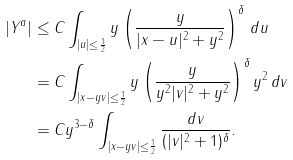Convert formula to latex. <formula><loc_0><loc_0><loc_500><loc_500>| Y ^ { a } | & \leq C \int _ { | u | \leq \frac { 1 } { 2 } } y \left ( \frac { y } { | x - u | ^ { 2 } + y ^ { 2 } } \right ) ^ { \delta } \, d u \\ & = C \int _ { | x - y v | \leq \frac { 1 } { 2 } } y \left ( \frac { y } { y ^ { 2 } | v | ^ { 2 } + y ^ { 2 } } \right ) ^ { \delta } y ^ { 2 } \, d v \\ & = C y ^ { 3 - \delta } \int _ { | x - y v | \leq \frac { 1 } { 2 } } \frac { d v } { ( | v | ^ { 2 } + 1 ) ^ { \delta } } .</formula> 